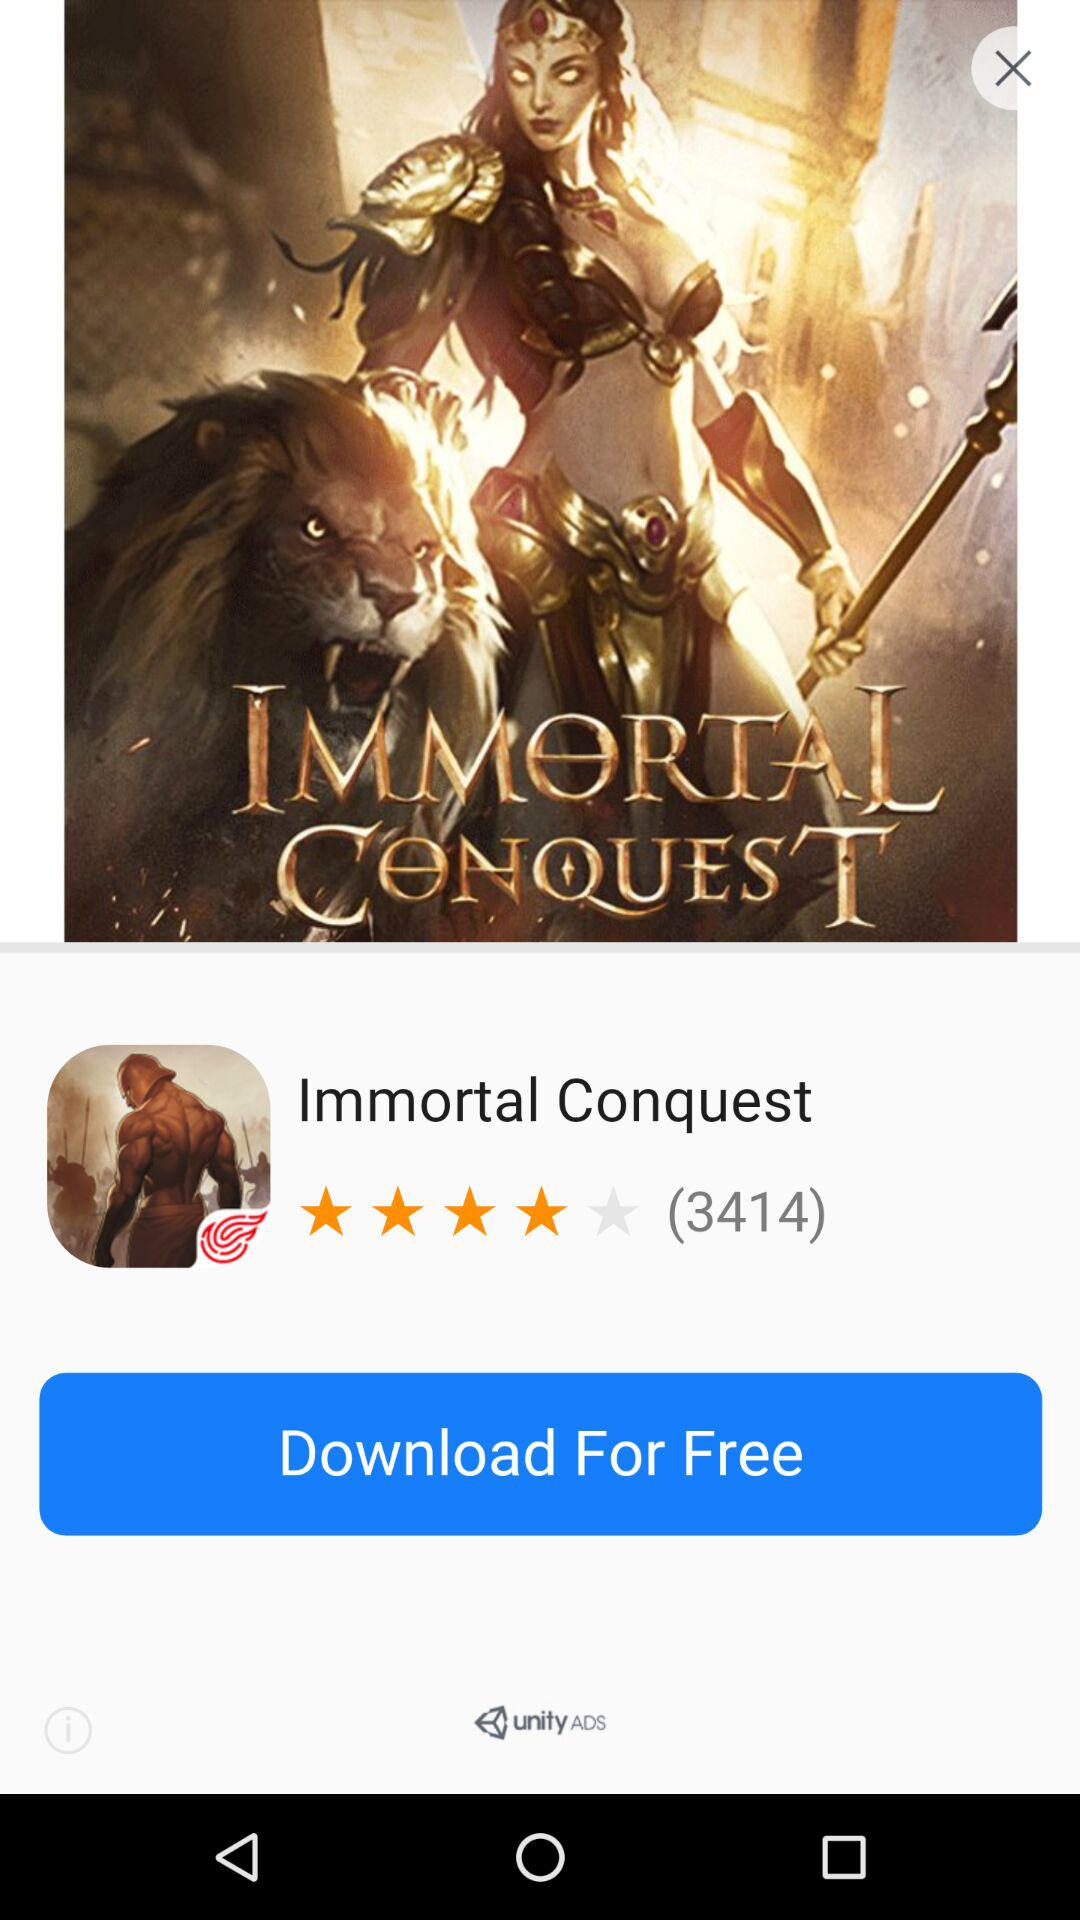How many stars does the "Immortal Conquest" get? The "Immortal Conquest" got 4 stars. 